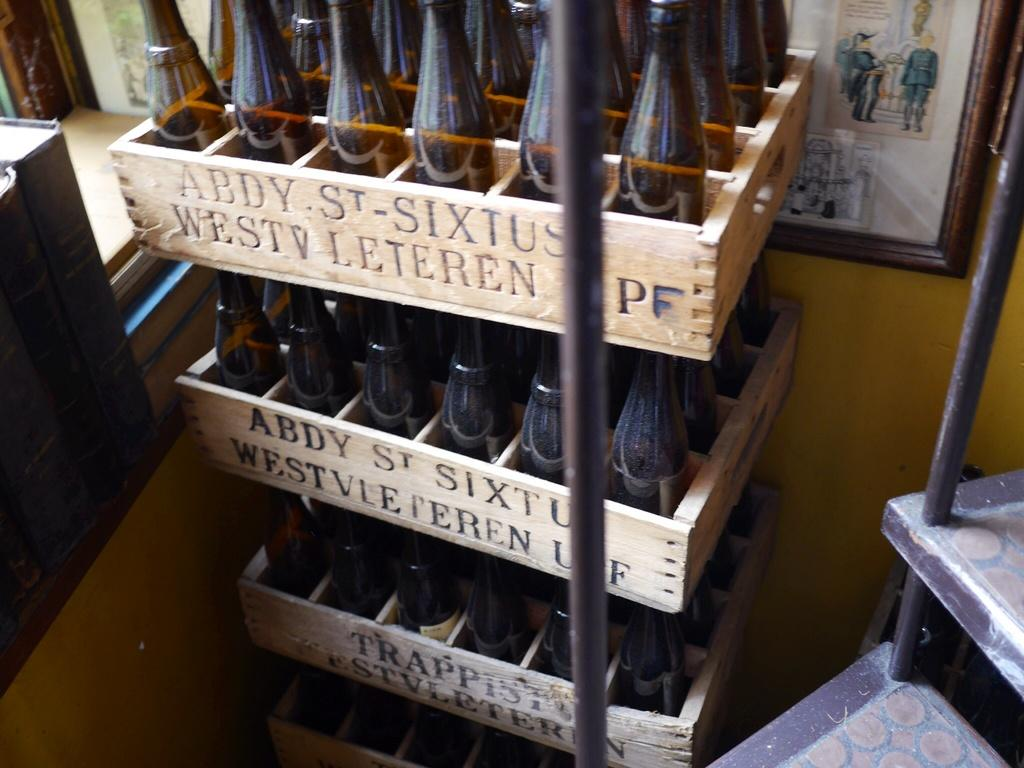<image>
Offer a succinct explanation of the picture presented. A crate that says Abdy St. Sixtus holds several bottles and is stacked with other crates. 